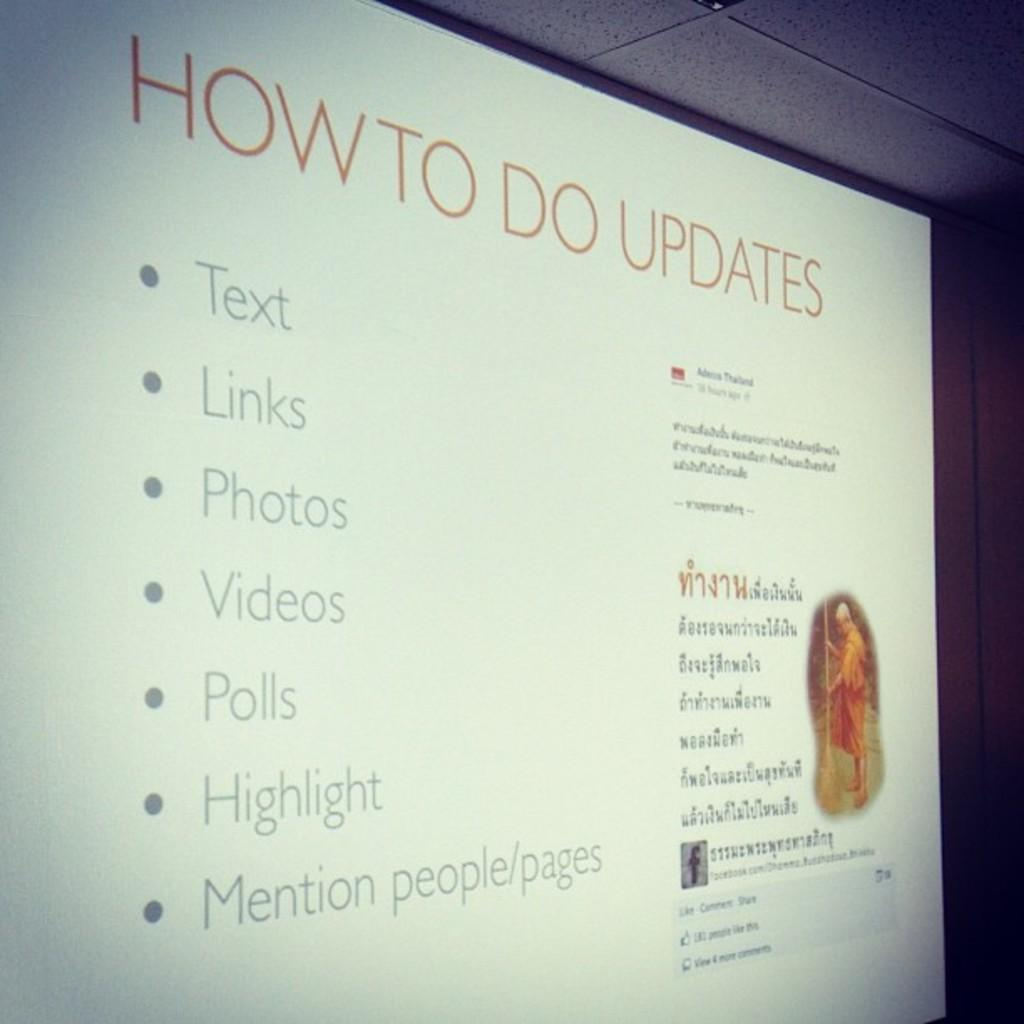<image>
Summarize the visual content of the image. A slide about "how to do updates" has a bullet point list of items on it. 